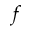Convert formula to latex. <formula><loc_0><loc_0><loc_500><loc_500>f</formula> 